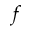Convert formula to latex. <formula><loc_0><loc_0><loc_500><loc_500>f</formula> 